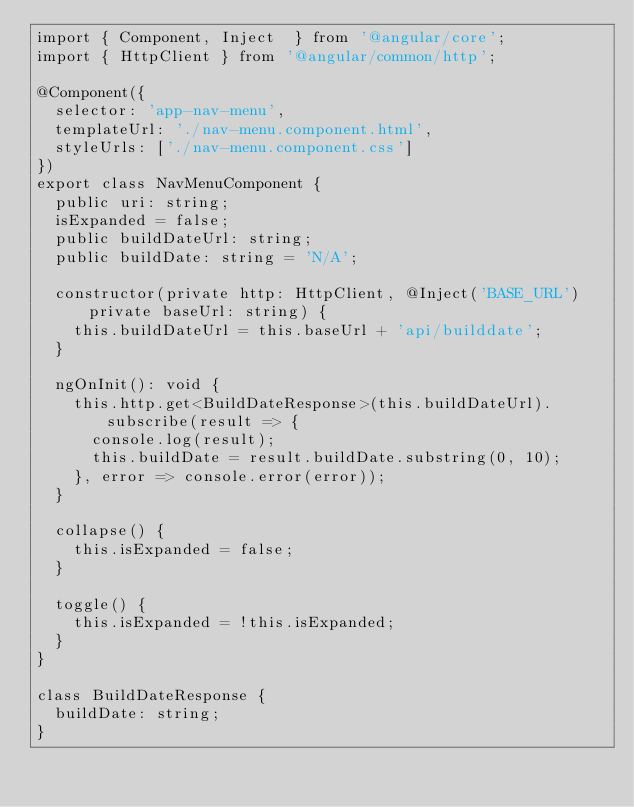<code> <loc_0><loc_0><loc_500><loc_500><_TypeScript_>import { Component, Inject  } from '@angular/core';
import { HttpClient } from '@angular/common/http';

@Component({
  selector: 'app-nav-menu',
  templateUrl: './nav-menu.component.html',
  styleUrls: ['./nav-menu.component.css']
})
export class NavMenuComponent {
  public uri: string;
  isExpanded = false;
  public buildDateUrl: string;
  public buildDate: string = 'N/A';

  constructor(private http: HttpClient, @Inject('BASE_URL') private baseUrl: string) {
    this.buildDateUrl = this.baseUrl + 'api/builddate';
  }

  ngOnInit(): void {
    this.http.get<BuildDateResponse>(this.buildDateUrl).subscribe(result => {
      console.log(result);
      this.buildDate = result.buildDate.substring(0, 10);
    }, error => console.error(error));
  }

  collapse() {
    this.isExpanded = false;
  }

  toggle() {
    this.isExpanded = !this.isExpanded;
  }
}

class BuildDateResponse {
  buildDate: string;
}
</code> 